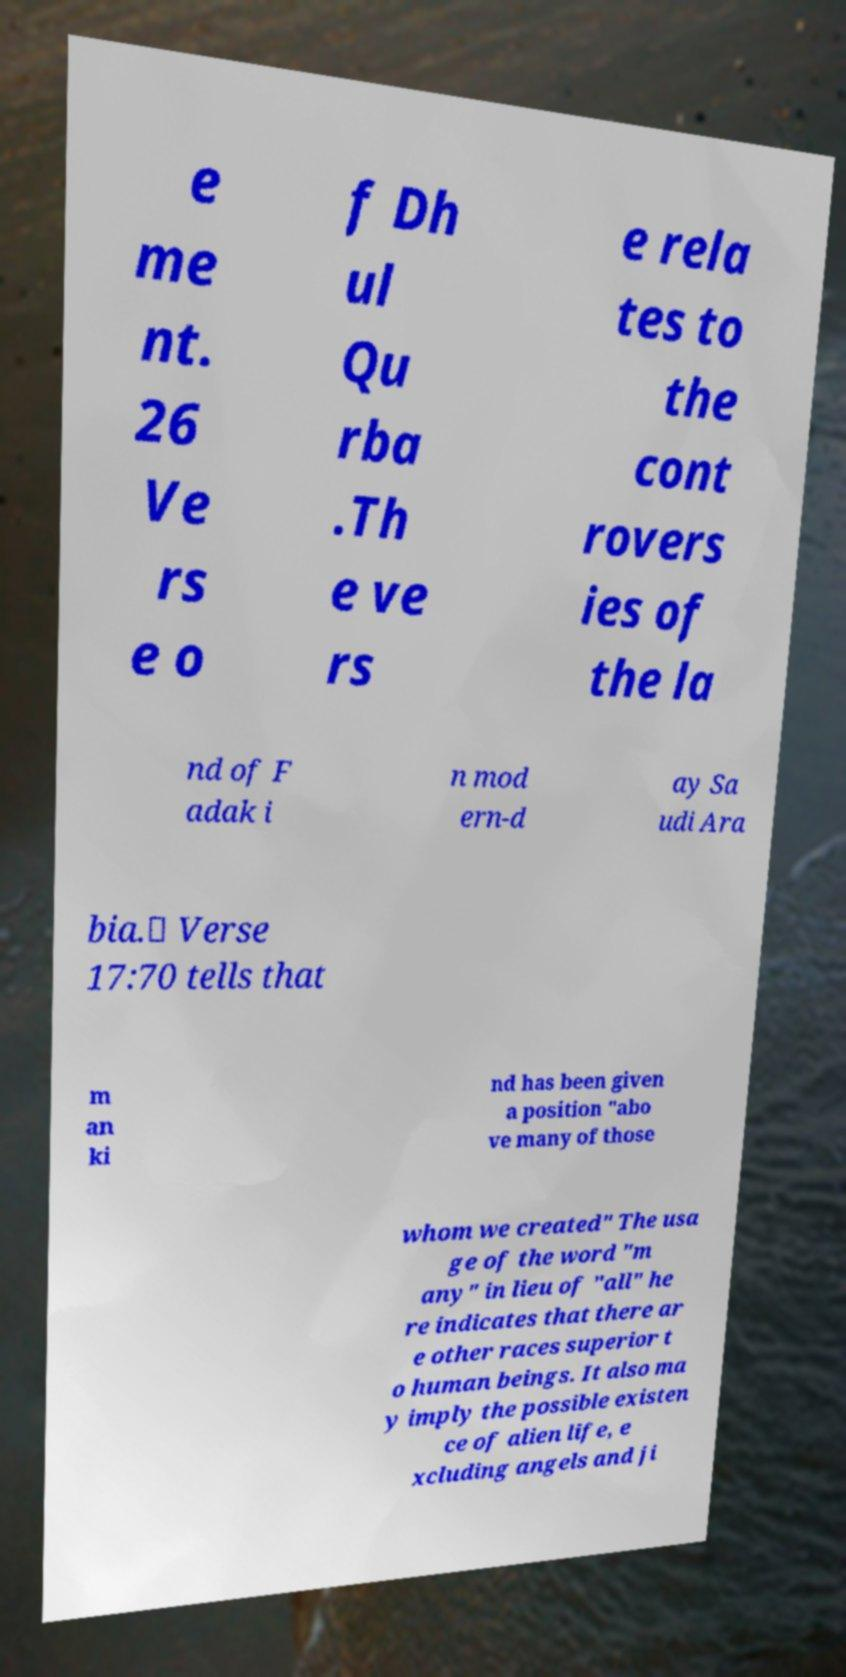Could you assist in decoding the text presented in this image and type it out clearly? e me nt. 26 Ve rs e o f Dh ul Qu rba .Th e ve rs e rela tes to the cont rovers ies of the la nd of F adak i n mod ern-d ay Sa udi Ara bia.۞ Verse 17:70 tells that m an ki nd has been given a position "abo ve many of those whom we created" The usa ge of the word "m any" in lieu of "all" he re indicates that there ar e other races superior t o human beings. It also ma y imply the possible existen ce of alien life, e xcluding angels and ji 